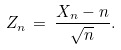Convert formula to latex. <formula><loc_0><loc_0><loc_500><loc_500>Z _ { n } \, = \, \frac { X _ { n } - n } { \sqrt { n } } .</formula> 